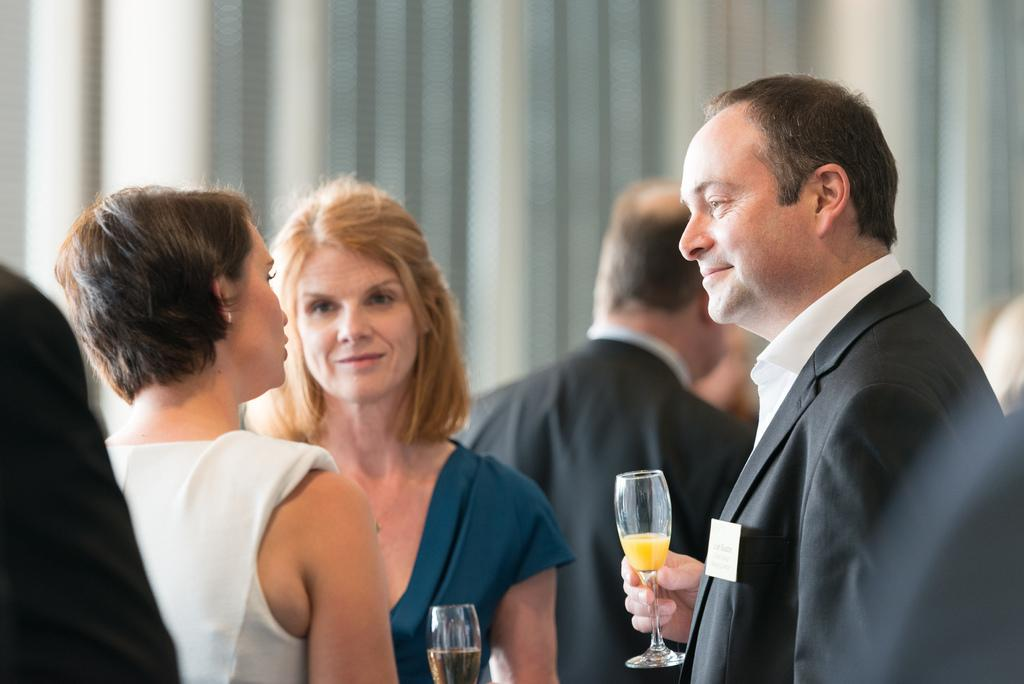What types of people are in the image? There are men and women in the image. What are the men and women wearing? The men and women are wearing suits. What are the men and women doing in the image? The men and women are talking. What are they holding in their hands? They are all holding wine glasses. What can be seen in the background of the image? There is a wall in the background of the image. What type of boot can be seen on the wall in the image? There is no boot present on the wall in the image. What is the engine used for in the image? There is no engine present in the image. 